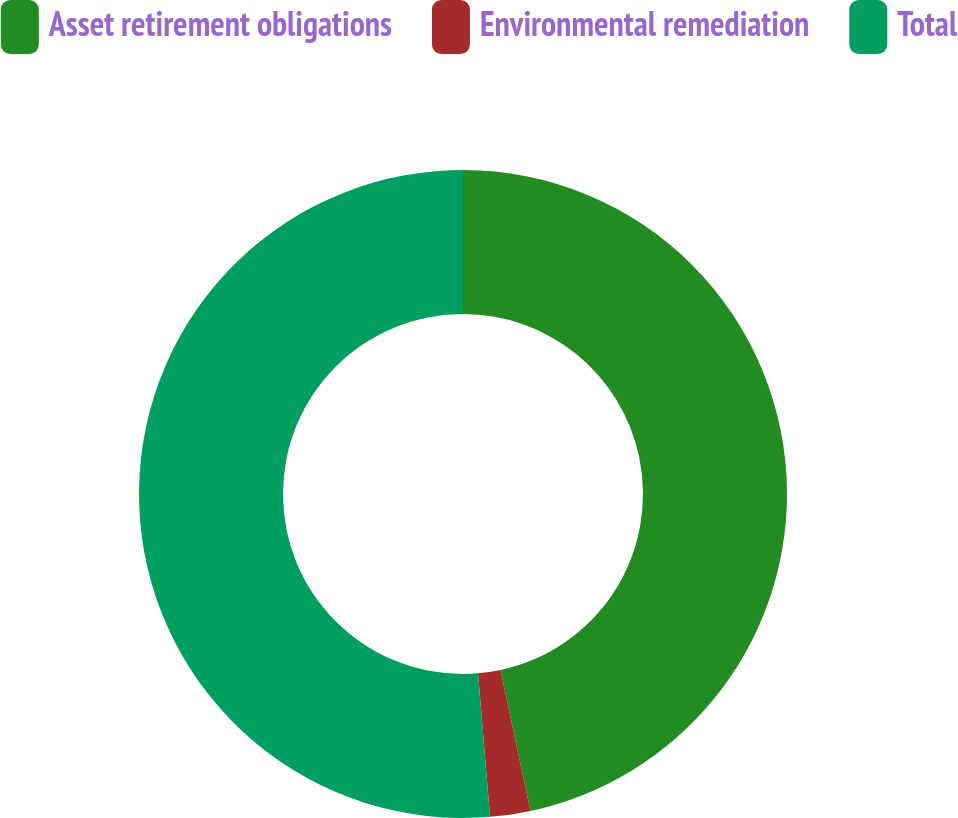Convert chart to OTSL. <chart><loc_0><loc_0><loc_500><loc_500><pie_chart><fcel>Asset retirement obligations<fcel>Environmental remediation<fcel>Total<nl><fcel>46.66%<fcel>2.01%<fcel>51.33%<nl></chart> 